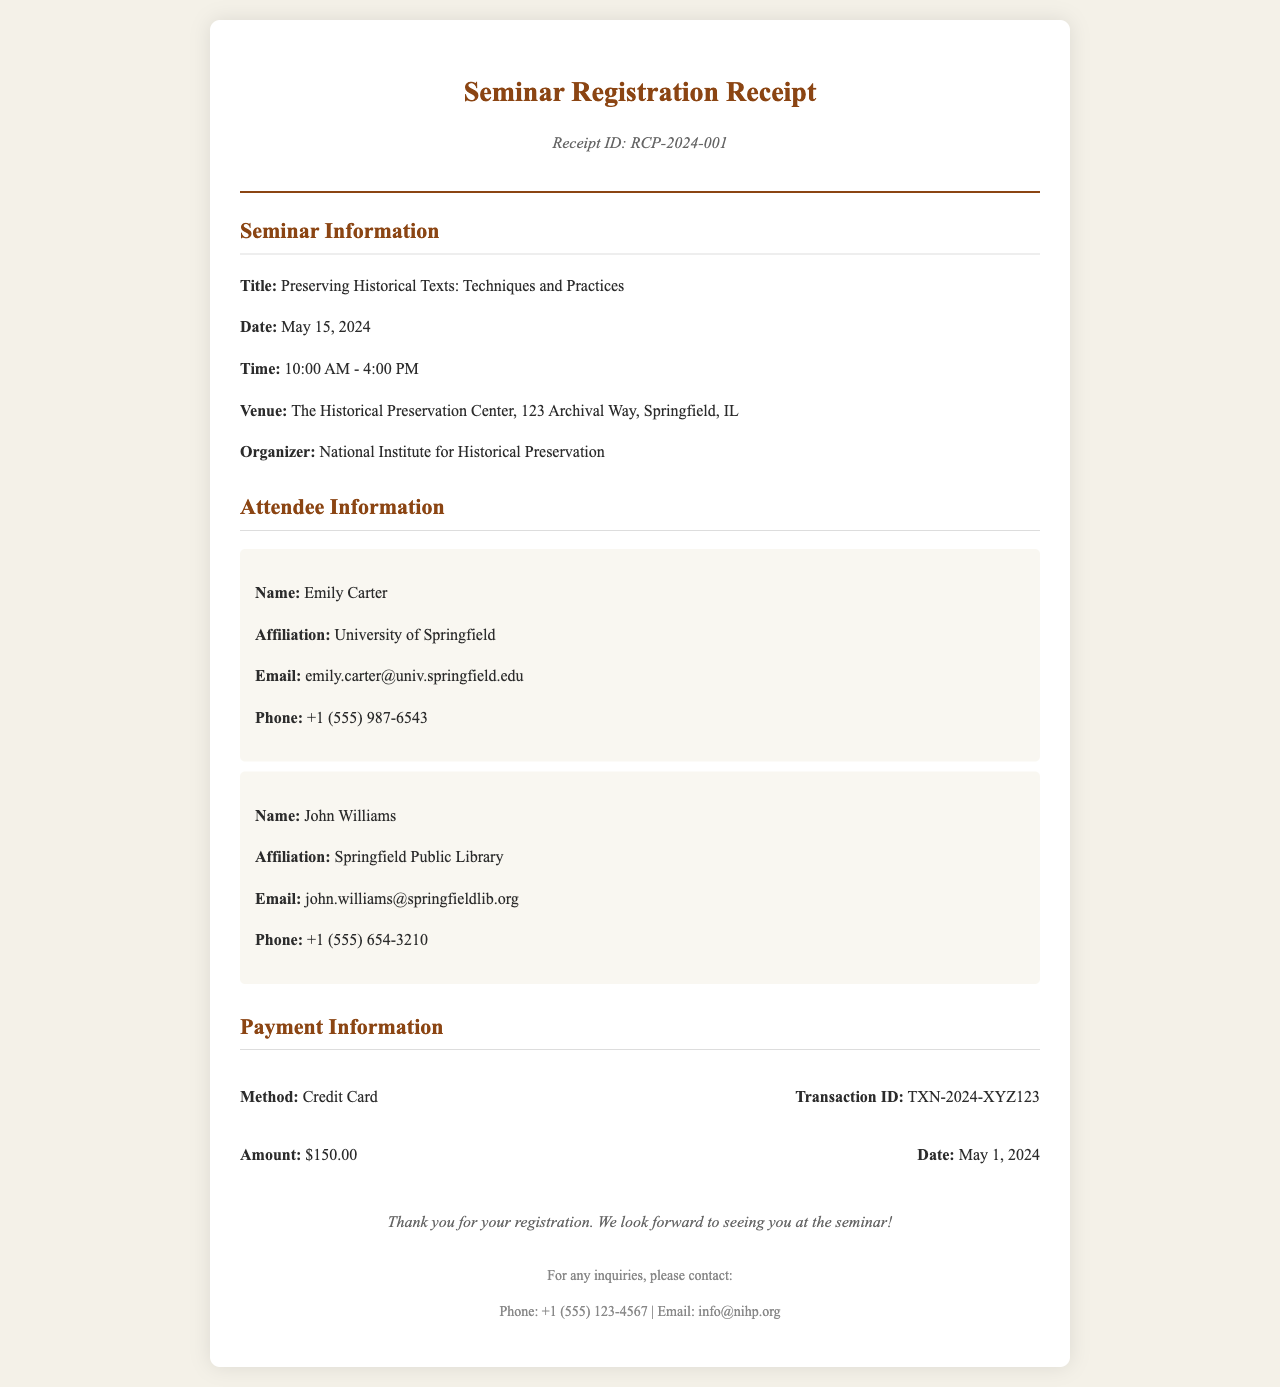What is the title of the seminar? The title is provided in the seminar details section, which is "Preserving Historical Texts: Techniques and Practices."
Answer: Preserving Historical Texts: Techniques and Practices What is the date of the seminar? The date is mentioned under seminar information, which is May 15, 2024.
Answer: May 15, 2024 Who is the organizer of the seminar? The organizer's name is stated in the seminar details, which is "National Institute for Historical Preservation."
Answer: National Institute for Historical Preservation What payment method was used for registration? The payment method is specified in the payment details and is listed as "Credit Card."
Answer: Credit Card How much was the registration fee? The amount is detailed in the payment information section and is $150.00.
Answer: $150.00 What is the email address of Emily Carter? The email address for Emily Carter is provided in her attendee details, which is "emily.carter@univ.springfield.edu."
Answer: emily.carter@univ.springfield.edu What is the receipt ID? The receipt ID is mentioned in the header as "RCP-2024-001."
Answer: RCP-2024-001 What is the transaction ID for the payment? The transaction ID is noted in the payment info section as "TXN-2024-XYZ123."
Answer: TXN-2024-XYZ123 What time does the seminar start? The starting time is indicated in the seminar details, which is 10:00 AM.
Answer: 10:00 AM 